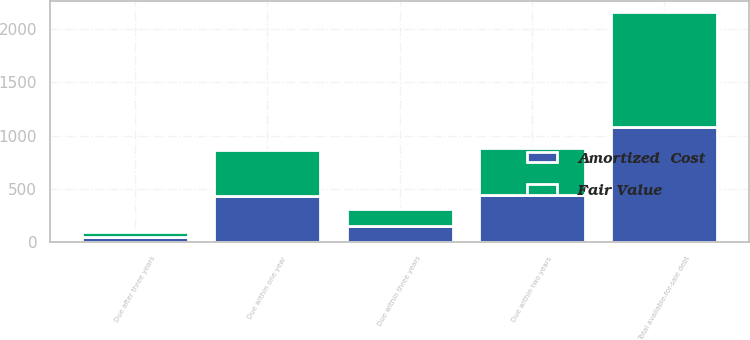Convert chart to OTSL. <chart><loc_0><loc_0><loc_500><loc_500><stacked_bar_chart><ecel><fcel>Due within one year<fcel>Due within two years<fcel>Due within three years<fcel>Due after three years<fcel>Total available-for-sale debt<nl><fcel>Fair Value<fcel>434<fcel>443<fcel>156<fcel>47<fcel>1080<nl><fcel>Amortized  Cost<fcel>435<fcel>442<fcel>156<fcel>46<fcel>1079<nl></chart> 